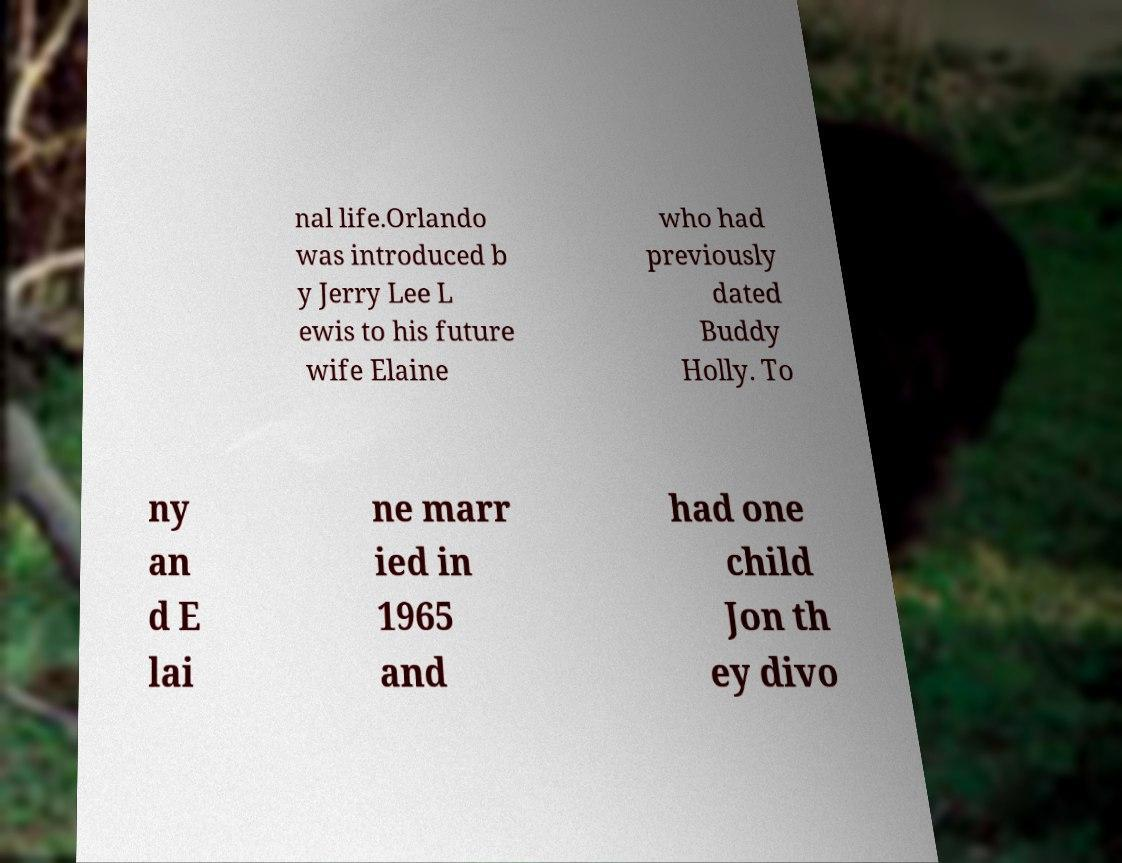Could you extract and type out the text from this image? nal life.Orlando was introduced b y Jerry Lee L ewis to his future wife Elaine who had previously dated Buddy Holly. To ny an d E lai ne marr ied in 1965 and had one child Jon th ey divo 